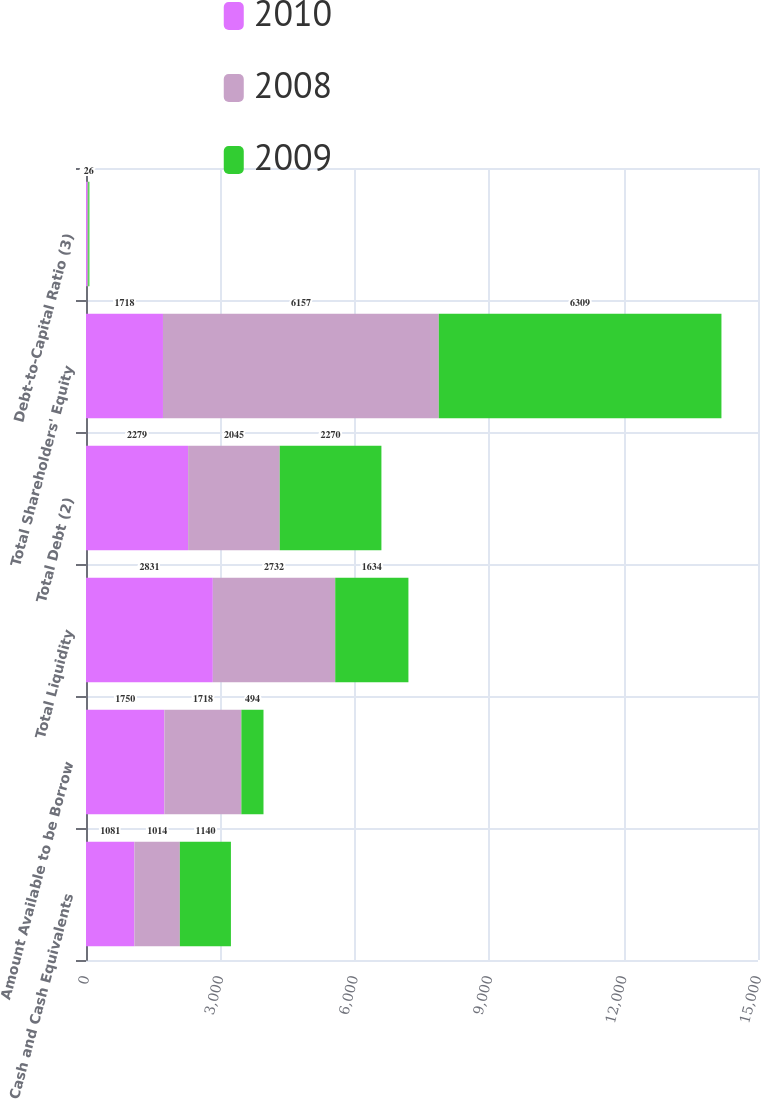Convert chart. <chart><loc_0><loc_0><loc_500><loc_500><stacked_bar_chart><ecel><fcel>Cash and Cash Equivalents<fcel>Amount Available to be Borrow<fcel>Total Liquidity<fcel>Total Debt (2)<fcel>Total Shareholders' Equity<fcel>Debt-to-Capital Ratio (3)<nl><fcel>2010<fcel>1081<fcel>1750<fcel>2831<fcel>2279<fcel>1718<fcel>25<nl><fcel>2008<fcel>1014<fcel>1718<fcel>2732<fcel>2045<fcel>6157<fcel>25<nl><fcel>2009<fcel>1140<fcel>494<fcel>1634<fcel>2270<fcel>6309<fcel>26<nl></chart> 